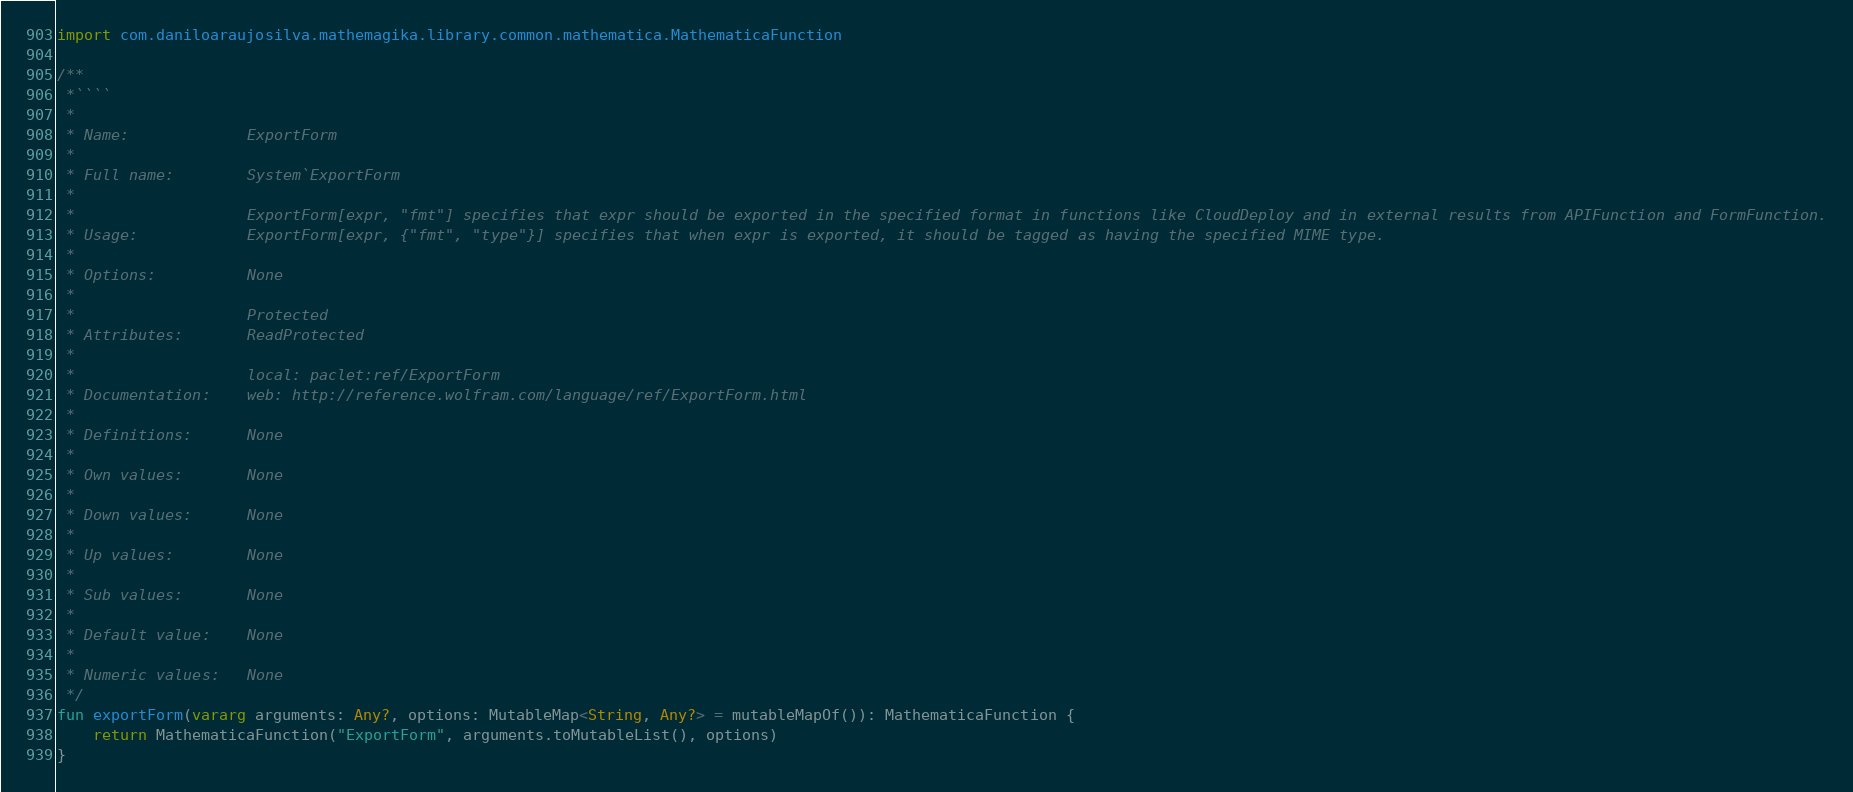Convert code to text. <code><loc_0><loc_0><loc_500><loc_500><_Kotlin_>import com.daniloaraujosilva.mathemagika.library.common.mathematica.MathematicaFunction

/**
 *````
 *
 * Name:             ExportForm
 *
 * Full name:        System`ExportForm
 *
 *                   ExportForm[expr, "fmt"] specifies that expr should be exported in the specified format in functions like CloudDeploy and in external results from APIFunction and FormFunction.
 * Usage:            ExportForm[expr, {"fmt", "type"}] specifies that when expr is exported, it should be tagged as having the specified MIME type.
 *
 * Options:          None
 *
 *                   Protected
 * Attributes:       ReadProtected
 *
 *                   local: paclet:ref/ExportForm
 * Documentation:    web: http://reference.wolfram.com/language/ref/ExportForm.html
 *
 * Definitions:      None
 *
 * Own values:       None
 *
 * Down values:      None
 *
 * Up values:        None
 *
 * Sub values:       None
 *
 * Default value:    None
 *
 * Numeric values:   None
 */
fun exportForm(vararg arguments: Any?, options: MutableMap<String, Any?> = mutableMapOf()): MathematicaFunction {
	return MathematicaFunction("ExportForm", arguments.toMutableList(), options)
}
</code> 